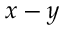Convert formula to latex. <formula><loc_0><loc_0><loc_500><loc_500>x - y</formula> 